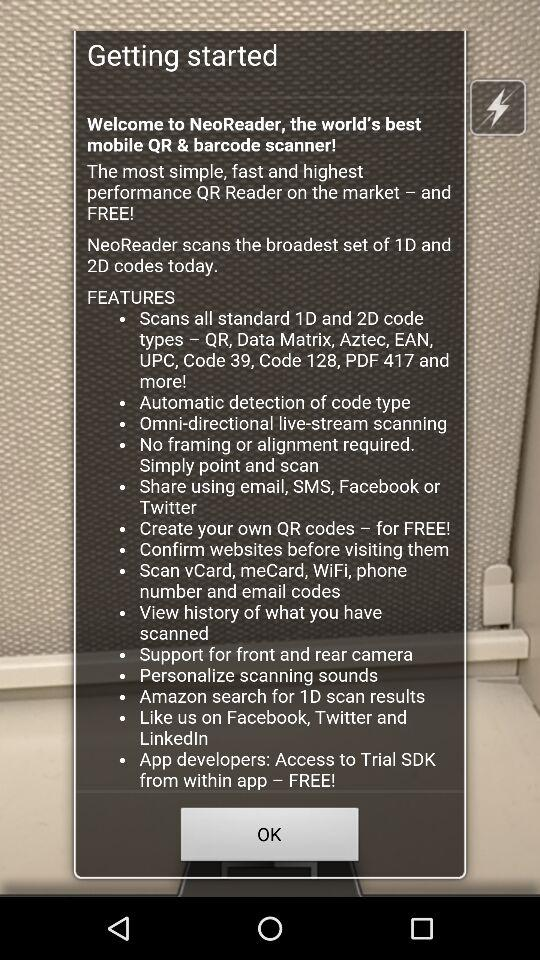Through which application can we share? You can share through "email", "SMS", "Facebook" and "Twitter". 